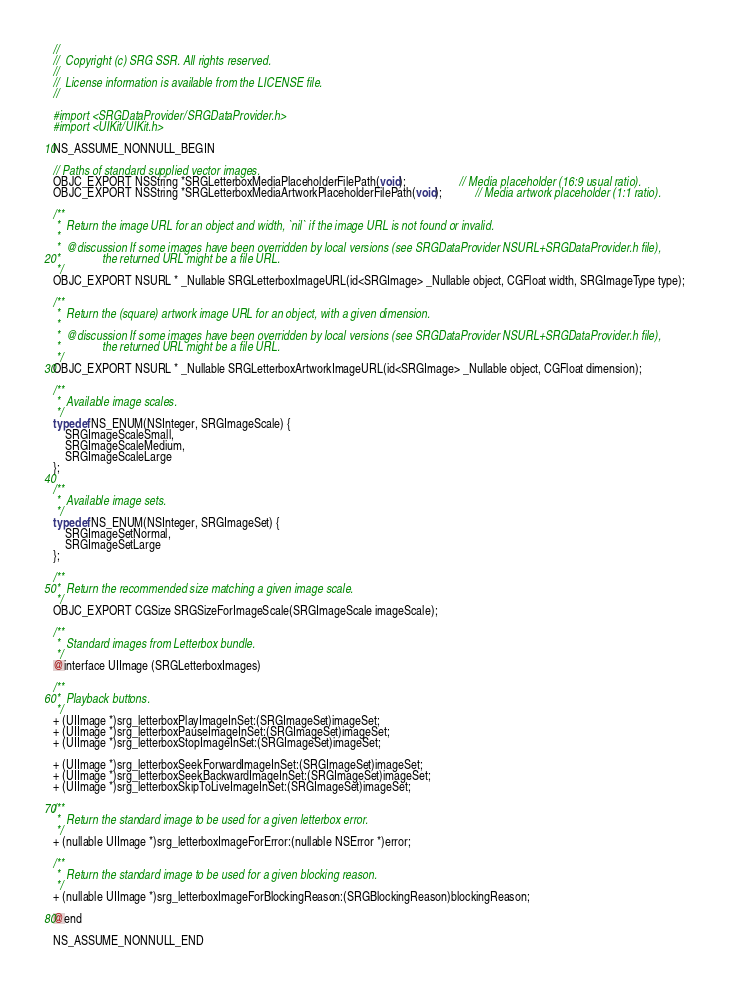Convert code to text. <code><loc_0><loc_0><loc_500><loc_500><_C_>//
//  Copyright (c) SRG SSR. All rights reserved.
//
//  License information is available from the LICENSE file.
//

#import <SRGDataProvider/SRGDataProvider.h>
#import <UIKit/UIKit.h>

NS_ASSUME_NONNULL_BEGIN

// Paths of standard supplied vector images.
OBJC_EXPORT NSString *SRGLetterboxMediaPlaceholderFilePath(void);                  // Media placeholder (16:9 usual ratio).
OBJC_EXPORT NSString *SRGLetterboxMediaArtworkPlaceholderFilePath(void);           // Media artwork placeholder (1:1 ratio).

/**
 *  Return the image URL for an object and width, `nil` if the image URL is not found or invalid.
 *
 *  @discussion If some images have been overridden by local versions (see SRGDataProvider NSURL+SRGDataProvider.h file),
 *              the returned URL might be a file URL.
 */
OBJC_EXPORT NSURL * _Nullable SRGLetterboxImageURL(id<SRGImage> _Nullable object, CGFloat width, SRGImageType type);

/**
 *  Return the (square) artwork image URL for an object, with a given dimension.
 *
 *  @discussion If some images have been overridden by local versions (see SRGDataProvider NSURL+SRGDataProvider.h file),
 *              the returned URL might be a file URL.
 */
OBJC_EXPORT NSURL * _Nullable SRGLetterboxArtworkImageURL(id<SRGImage> _Nullable object, CGFloat dimension);

/**
 *  Available image scales.
 */
typedef NS_ENUM(NSInteger, SRGImageScale) {
    SRGImageScaleSmall,
    SRGImageScaleMedium,
    SRGImageScaleLarge
};

/**
 *  Available image sets.
 */
typedef NS_ENUM(NSInteger, SRGImageSet) {
    SRGImageSetNormal,
    SRGImageSetLarge
};

/**
 *  Return the recommended size matching a given image scale.
 */
OBJC_EXPORT CGSize SRGSizeForImageScale(SRGImageScale imageScale);

/**
 *  Standard images from Letterbox bundle.
 */
@interface UIImage (SRGLetterboxImages)

/**
 *  Playback buttons.
 */
+ (UIImage *)srg_letterboxPlayImageInSet:(SRGImageSet)imageSet;
+ (UIImage *)srg_letterboxPauseImageInSet:(SRGImageSet)imageSet;
+ (UIImage *)srg_letterboxStopImageInSet:(SRGImageSet)imageSet;

+ (UIImage *)srg_letterboxSeekForwardImageInSet:(SRGImageSet)imageSet;
+ (UIImage *)srg_letterboxSeekBackwardImageInSet:(SRGImageSet)imageSet;
+ (UIImage *)srg_letterboxSkipToLiveImageInSet:(SRGImageSet)imageSet;

/**
 *  Return the standard image to be used for a given letterbox error.
 */
+ (nullable UIImage *)srg_letterboxImageForError:(nullable NSError *)error;

/**
 *  Return the standard image to be used for a given blocking reason.
 */
+ (nullable UIImage *)srg_letterboxImageForBlockingReason:(SRGBlockingReason)blockingReason;

@end

NS_ASSUME_NONNULL_END
</code> 